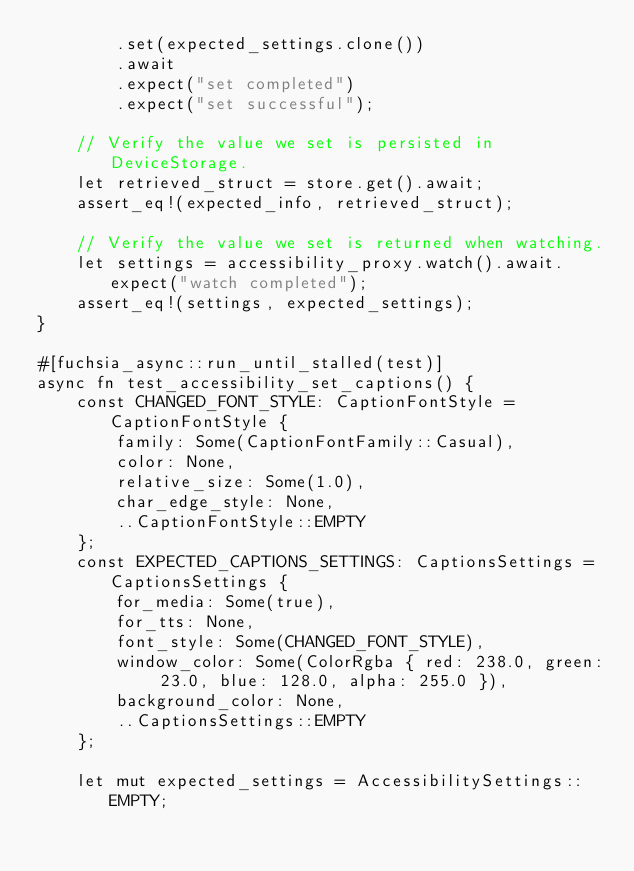<code> <loc_0><loc_0><loc_500><loc_500><_Rust_>        .set(expected_settings.clone())
        .await
        .expect("set completed")
        .expect("set successful");

    // Verify the value we set is persisted in DeviceStorage.
    let retrieved_struct = store.get().await;
    assert_eq!(expected_info, retrieved_struct);

    // Verify the value we set is returned when watching.
    let settings = accessibility_proxy.watch().await.expect("watch completed");
    assert_eq!(settings, expected_settings);
}

#[fuchsia_async::run_until_stalled(test)]
async fn test_accessibility_set_captions() {
    const CHANGED_FONT_STYLE: CaptionFontStyle = CaptionFontStyle {
        family: Some(CaptionFontFamily::Casual),
        color: None,
        relative_size: Some(1.0),
        char_edge_style: None,
        ..CaptionFontStyle::EMPTY
    };
    const EXPECTED_CAPTIONS_SETTINGS: CaptionsSettings = CaptionsSettings {
        for_media: Some(true),
        for_tts: None,
        font_style: Some(CHANGED_FONT_STYLE),
        window_color: Some(ColorRgba { red: 238.0, green: 23.0, blue: 128.0, alpha: 255.0 }),
        background_color: None,
        ..CaptionsSettings::EMPTY
    };

    let mut expected_settings = AccessibilitySettings::EMPTY;</code> 